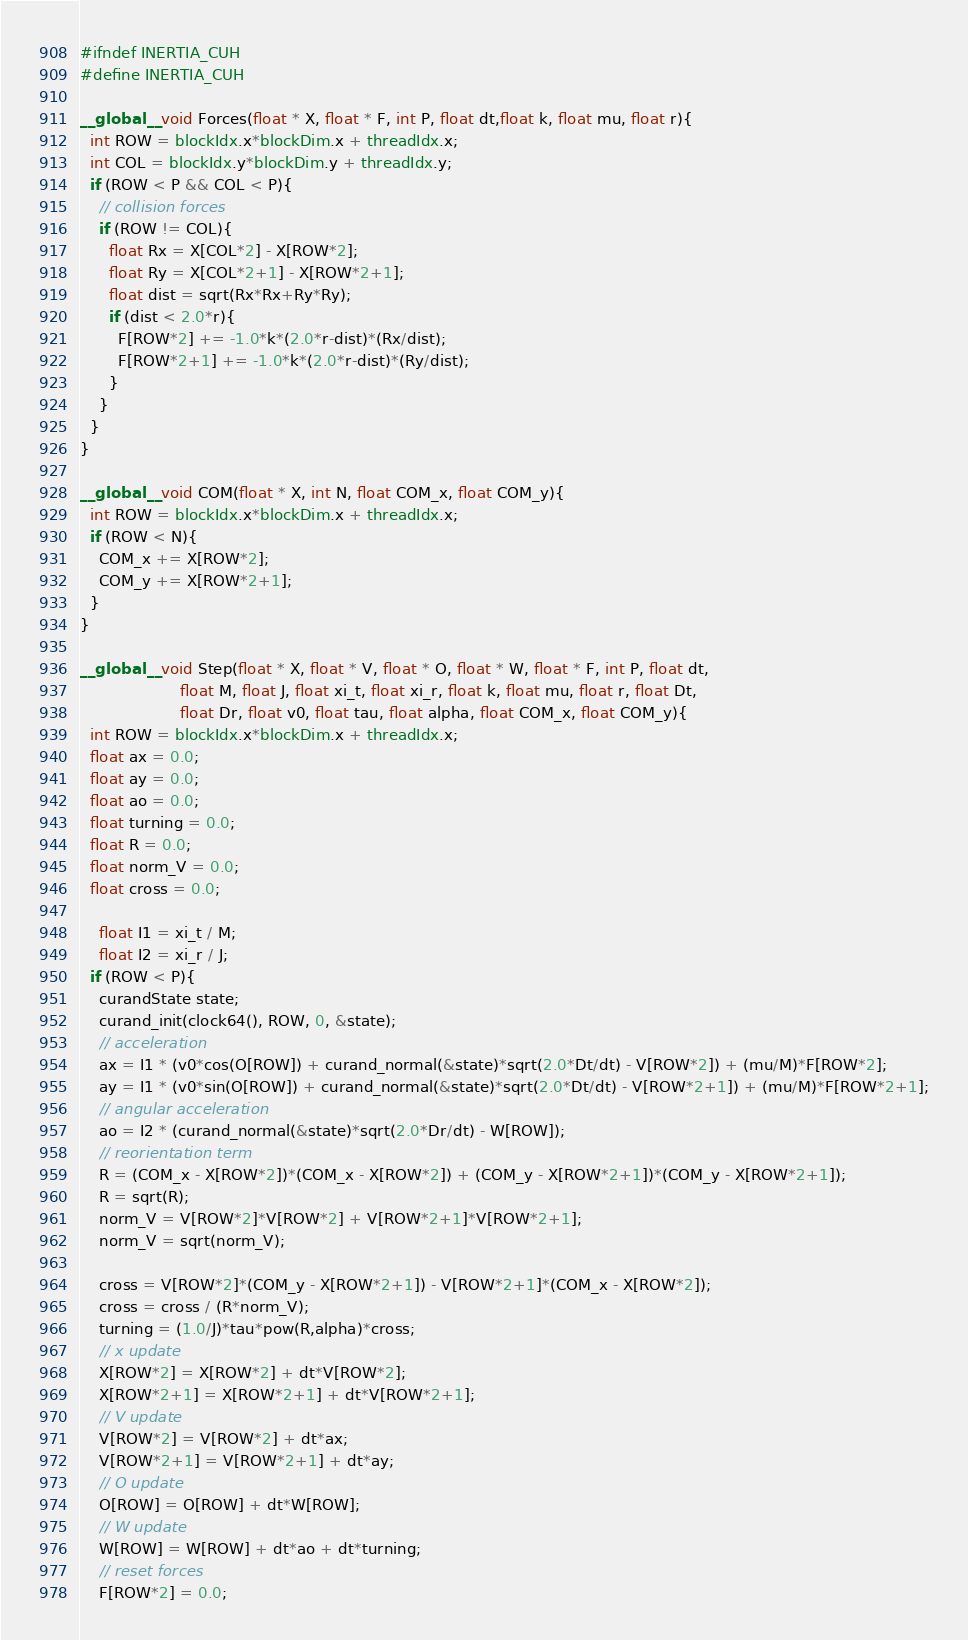Convert code to text. <code><loc_0><loc_0><loc_500><loc_500><_Cuda_>#ifndef INERTIA_CUH
#define INERTIA_CUH

__global__ void Forces(float * X, float * F, int P, float dt,float k, float mu, float r){
  int ROW = blockIdx.x*blockDim.x + threadIdx.x;
  int COL = blockIdx.y*blockDim.y + threadIdx.y;
  if (ROW < P && COL < P){
    // collision forces
    if (ROW != COL){
      float Rx = X[COL*2] - X[ROW*2];
      float Ry = X[COL*2+1] - X[ROW*2+1];
      float dist = sqrt(Rx*Rx+Ry*Ry);
      if (dist < 2.0*r){
        F[ROW*2] += -1.0*k*(2.0*r-dist)*(Rx/dist);
        F[ROW*2+1] += -1.0*k*(2.0*r-dist)*(Ry/dist);
      }
    }
  }
}

__global__ void COM(float * X, int N, float COM_x, float COM_y){
  int ROW = blockIdx.x*blockDim.x + threadIdx.x;
  if (ROW < N){
    COM_x += X[ROW*2];
    COM_y += X[ROW*2+1];
  }
}

__global__ void Step(float * X, float * V, float * O, float * W, float * F, int P, float dt,
                     float M, float J, float xi_t, float xi_r, float k, float mu, float r, float Dt,
                     float Dr, float v0, float tau, float alpha, float COM_x, float COM_y){
  int ROW = blockIdx.x*blockDim.x + threadIdx.x;
  float ax = 0.0;
  float ay = 0.0;
  float ao = 0.0;
  float turning = 0.0;
  float R = 0.0;
  float norm_V = 0.0;
  float cross = 0.0;

	float I1 = xi_t / M;
	float I2 = xi_r / J;
  if (ROW < P){
    curandState state;
    curand_init(clock64(), ROW, 0, &state);
    // acceleration
    ax = I1 * (v0*cos(O[ROW]) + curand_normal(&state)*sqrt(2.0*Dt/dt) - V[ROW*2]) + (mu/M)*F[ROW*2];
    ay = I1 * (v0*sin(O[ROW]) + curand_normal(&state)*sqrt(2.0*Dt/dt) - V[ROW*2+1]) + (mu/M)*F[ROW*2+1];
    // angular acceleration
    ao = I2 * (curand_normal(&state)*sqrt(2.0*Dr/dt) - W[ROW]);
    // reorientation term
    R = (COM_x - X[ROW*2])*(COM_x - X[ROW*2]) + (COM_y - X[ROW*2+1])*(COM_y - X[ROW*2+1]);
    R = sqrt(R);
    norm_V = V[ROW*2]*V[ROW*2] + V[ROW*2+1]*V[ROW*2+1];
    norm_V = sqrt(norm_V);

    cross = V[ROW*2]*(COM_y - X[ROW*2+1]) - V[ROW*2+1]*(COM_x - X[ROW*2]);
    cross = cross / (R*norm_V);
    turning = (1.0/J)*tau*pow(R,alpha)*cross;
    // x update
    X[ROW*2] = X[ROW*2] + dt*V[ROW*2];
    X[ROW*2+1] = X[ROW*2+1] + dt*V[ROW*2+1];
    // V update
    V[ROW*2] = V[ROW*2] + dt*ax;
    V[ROW*2+1] = V[ROW*2+1] + dt*ay;
    // O update
    O[ROW] = O[ROW] + dt*W[ROW];
    // W update
    W[ROW] = W[ROW] + dt*ao + dt*turning;
    // reset forces
    F[ROW*2] = 0.0;</code> 